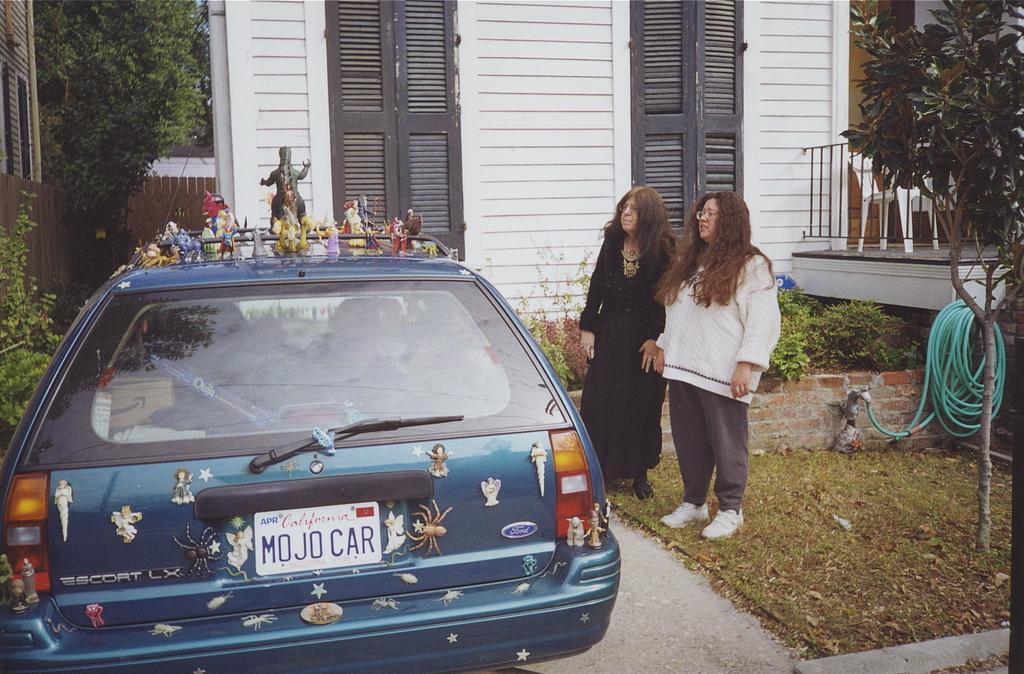Describe this image in one or two sentences. In this image we can see a car that is placed on the ground and toys placed on the top of it. In the background we can see wooden grill, climbers, building, windows, iron grill, chairs, tree, pipeline, grass, shredded leaves, bushes and two women standing on the ground. 